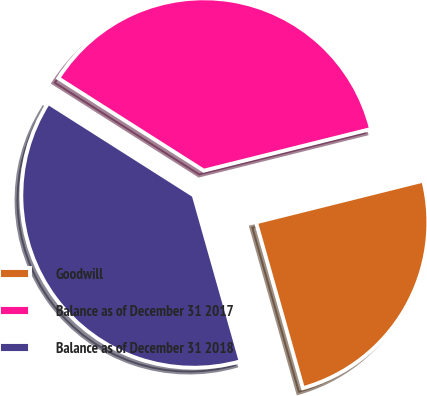Convert chart. <chart><loc_0><loc_0><loc_500><loc_500><pie_chart><fcel>Goodwill<fcel>Balance as of December 31 2017<fcel>Balance as of December 31 2018<nl><fcel>24.5%<fcel>37.1%<fcel>38.4%<nl></chart> 